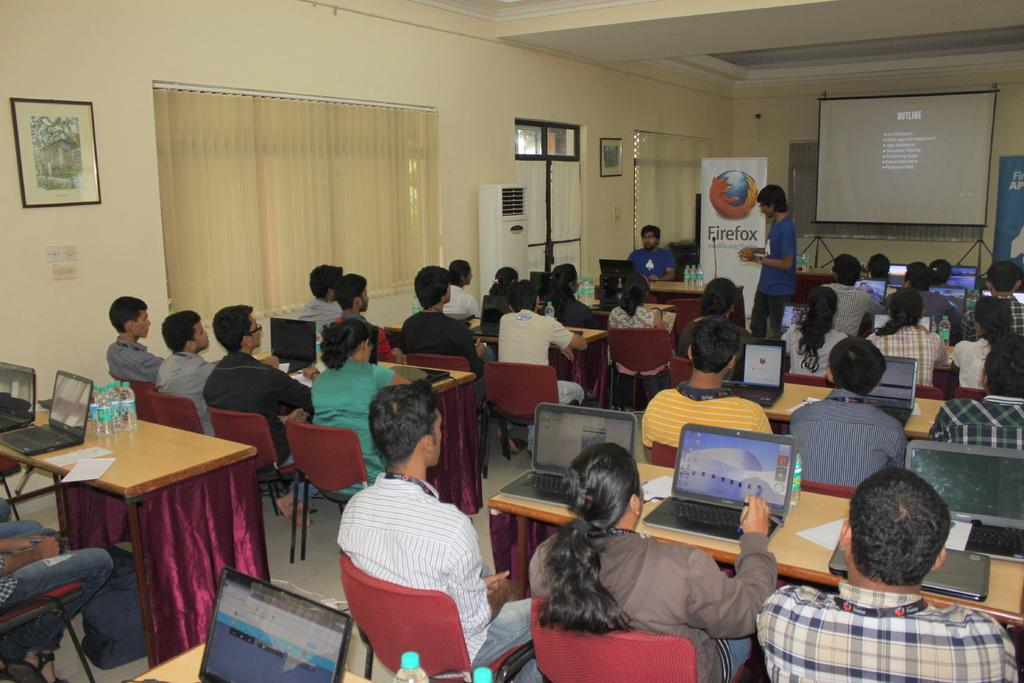What type of room is shown in the image? The image depicts a meeting room. What are the people in the room doing? People are seated with their laptops in the room. What is the purpose of the projector screen in the room? The projector screen is likely used for presentations or displaying information during the meeting. Can you describe the person standing in the room? There is a person standing in the room, but their specific role or activity cannot be determined from the image. What is visible outside the room through a window or door? There is a hoarding visible in the image, which suggests that the meeting room is located near an outdoor advertising display. How many grains of sand can be seen on the projector screen in the screen in the image? There is no sand visible on the projector screen in the image. What type of shock is the person standing in the room experiencing? There is no indication in the image that the person standing in the room is experiencing any shock. 